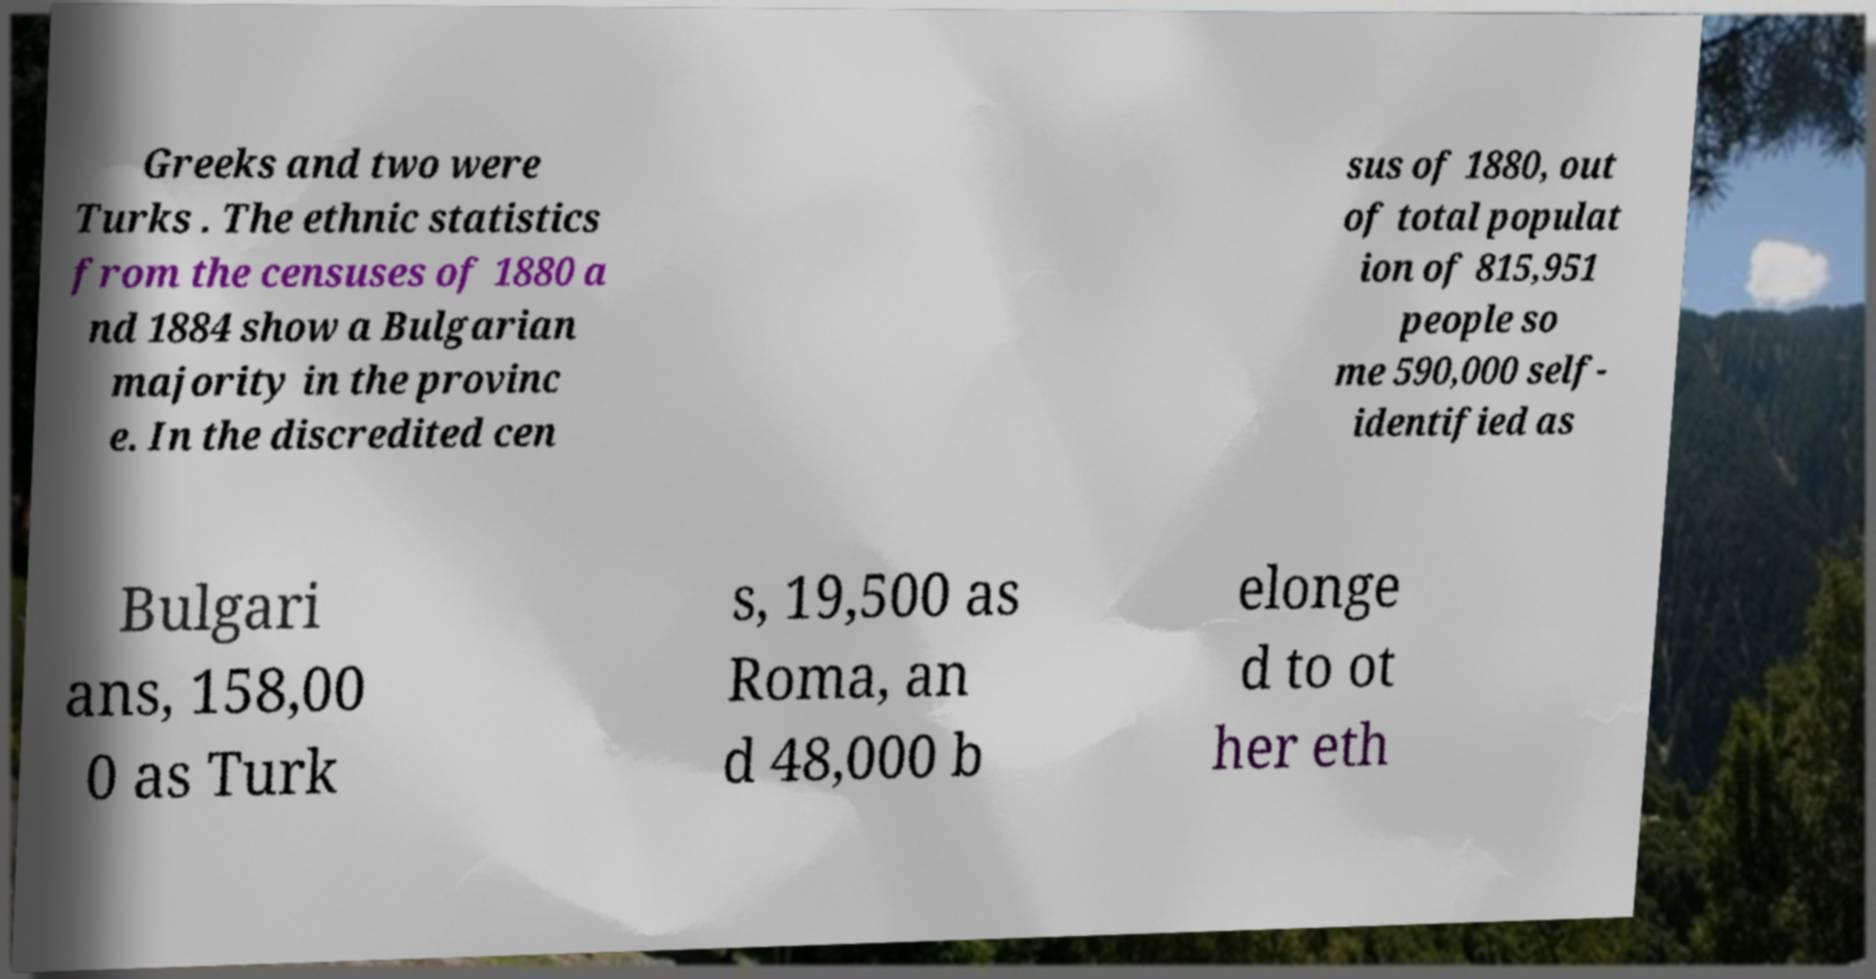Can you accurately transcribe the text from the provided image for me? Greeks and two were Turks . The ethnic statistics from the censuses of 1880 a nd 1884 show a Bulgarian majority in the provinc e. In the discredited cen sus of 1880, out of total populat ion of 815,951 people so me 590,000 self- identified as Bulgari ans, 158,00 0 as Turk s, 19,500 as Roma, an d 48,000 b elonge d to ot her eth 